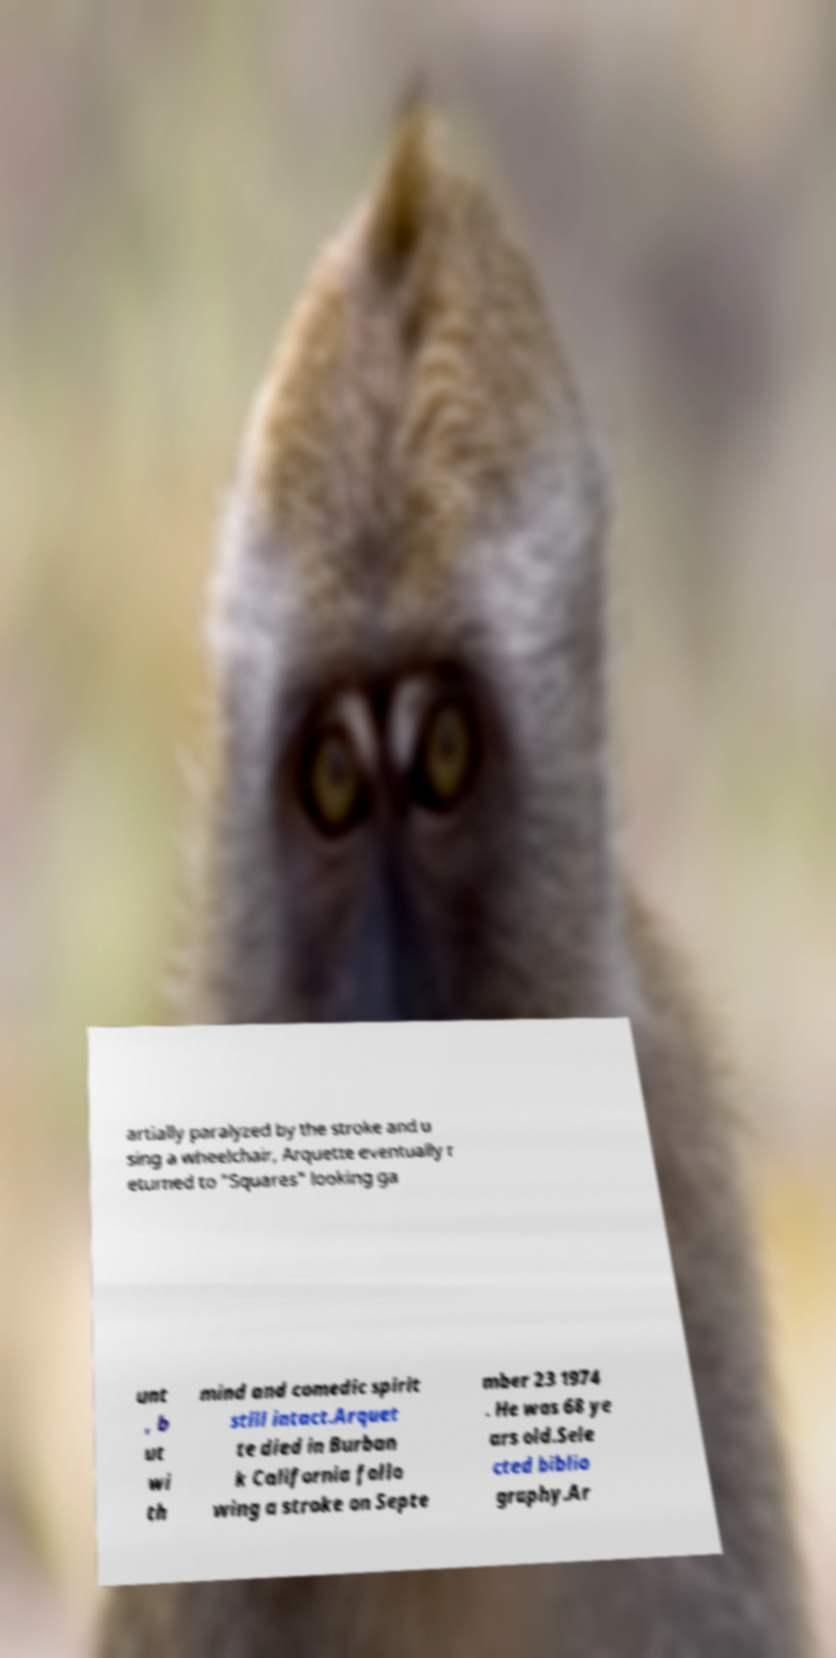There's text embedded in this image that I need extracted. Can you transcribe it verbatim? artially paralyzed by the stroke and u sing a wheelchair, Arquette eventually r eturned to "Squares" looking ga unt , b ut wi th mind and comedic spirit still intact.Arquet te died in Burban k California follo wing a stroke on Septe mber 23 1974 . He was 68 ye ars old.Sele cted biblio graphy.Ar 